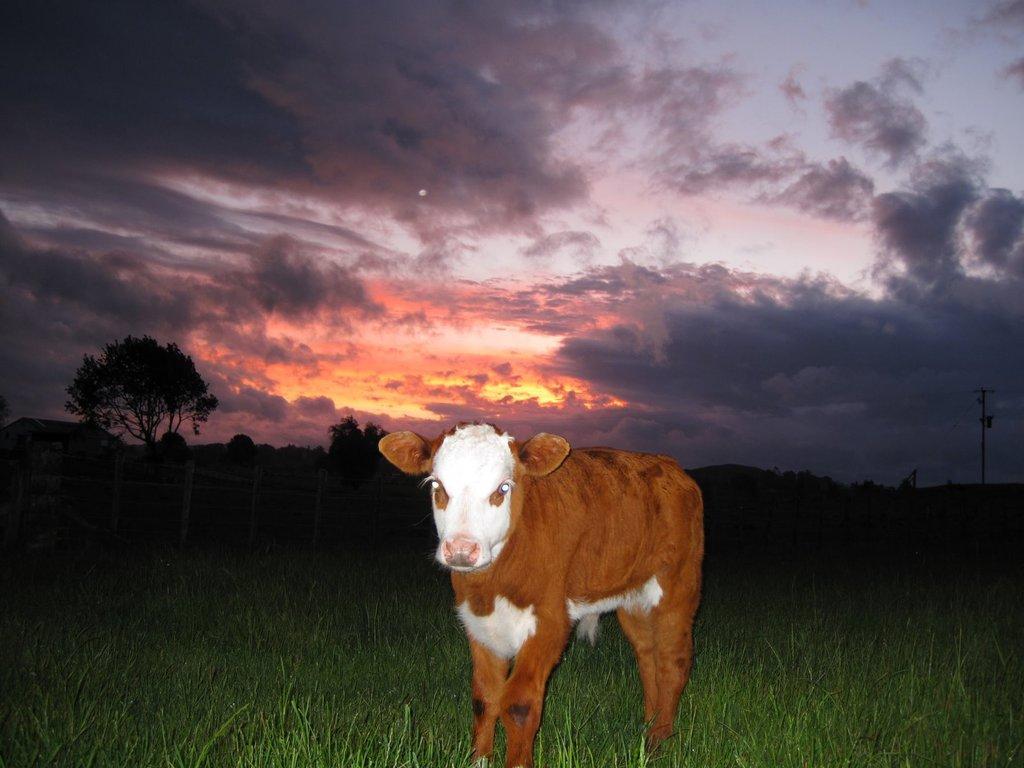How would you summarize this image in a sentence or two? This picture shows a calf and we see trees and grass on the ground and a pole and we see a cloudy sky. 